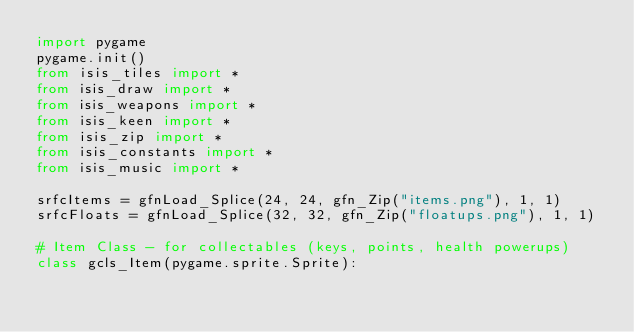<code> <loc_0><loc_0><loc_500><loc_500><_Python_>import pygame
pygame.init()
from isis_tiles import *
from isis_draw import *
from isis_weapons import *
from isis_keen import *
from isis_zip import *
from isis_constants import *
from isis_music import *
                
srfcItems = gfnLoad_Splice(24, 24, gfn_Zip("items.png"), 1, 1)
srfcFloats = gfnLoad_Splice(32, 32, gfn_Zip("floatups.png"), 1, 1)

# Item Class - for collectables (keys, points, health powerups)
class gcls_Item(pygame.sprite.Sprite):</code> 